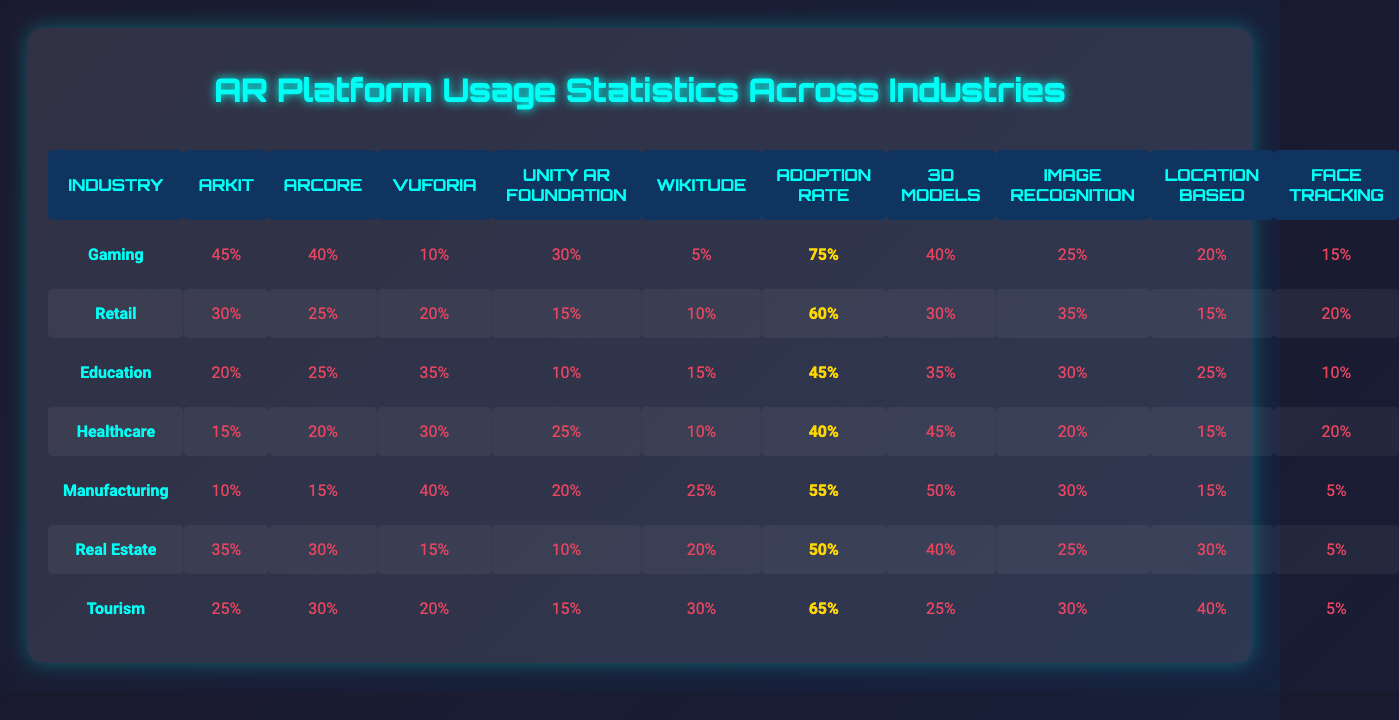What is the adoption rate for the Gaming industry? Looking at the table, the adoption rate for the Gaming industry is specifically listed under the "Adoption Rate" column. It shows a value of 75%.
Answer: 75% Which industry utilizes Vuforia the most? In the table, the highest percentage for Vuforia is seen under the Manufacturing industry, with a value of 40%. This is greater than any other industry's Vuforia usage.
Answer: Manufacturing What is the total percentage of ARKit usage across all industries? To find the total ARKit usage, we sum the values from the ARKit column: 45 + 30 + 20 + 15 + 10 + 35 + 25 = 180.
Answer: 180% Is the usage of ARCore higher in Retail or Education? By comparing the ARCore usage values for Retail (25%) and Education (25%), they are equal, so neither has a higher ARCore usage.
Answer: No Which industry has the highest percentage of 3D model usage? Referring to the “3D Models” column, the industry with the highest percentage is Manufacturing with a usage of 50%.
Answer: Manufacturing How many industries have an adoption rate below 50%? In the "Adoption Rate" column, only Education (45%) and Healthcare (40%) have adoption rates below 50%. Counting these gives us 2 industries.
Answer: 2 What is the average usage percentage of Unity AR Foundation across all industries? To calculate the average for Unity AR Foundation, we sum the values (30 + 15 + 10 + 25 + 20 + 10 + 15) = 125 and divide by the number of industries (7), which results in an average of approximately 17.86%.
Answer: 17.86% Is it true that the Healthcare industry has a higher percentage of face tracking than the Education industry? The face tracking usage for Healthcare is 20%, while for Education it is 10%. Since 20% is greater than 10%, this statement is true.
Answer: Yes Which industry has the least usage of Wikitude? Looking under the Wikitude column, Gaming (5%) has the least usage compared to other industries' Wikitude values.
Answer: Gaming If we compare ARKit and ARCore usage in the Real Estate industry, which one has a higher percentage? The Real Estate industry has 35% usage of ARKit compared to 30% for ARCore. Since 35% is greater, ARKit usage is higher.
Answer: ARKit 